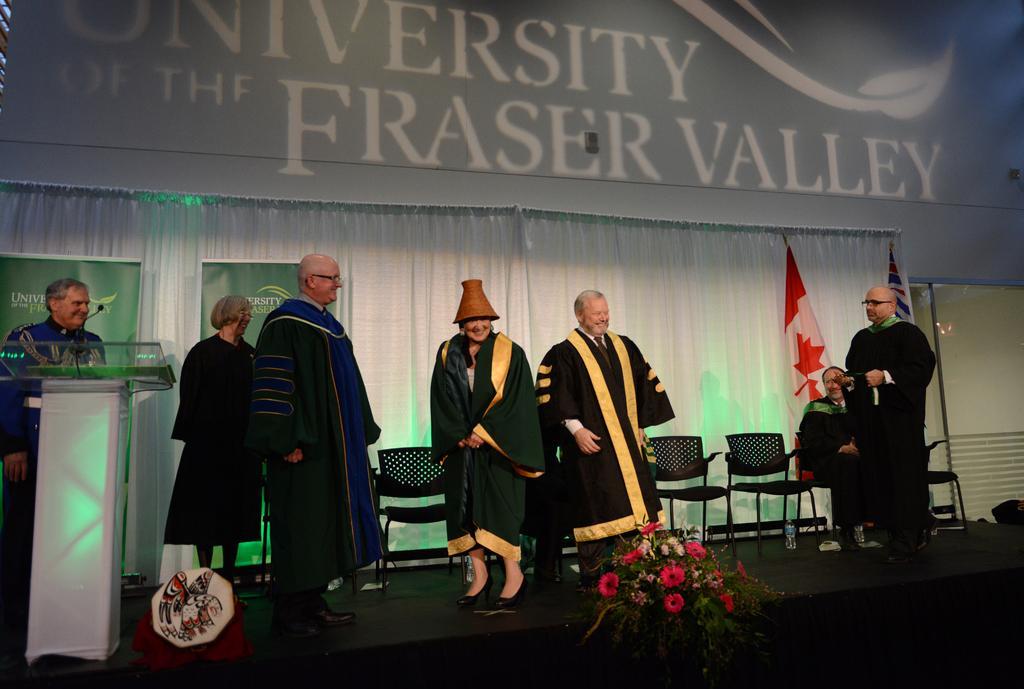How would you summarize this image in a sentence or two? In the image there are many old people standing on the stage with a graduation coat, behind them there is curtain with chairs in front of it and a flag, at the very front there is a flower vase on the stage. 